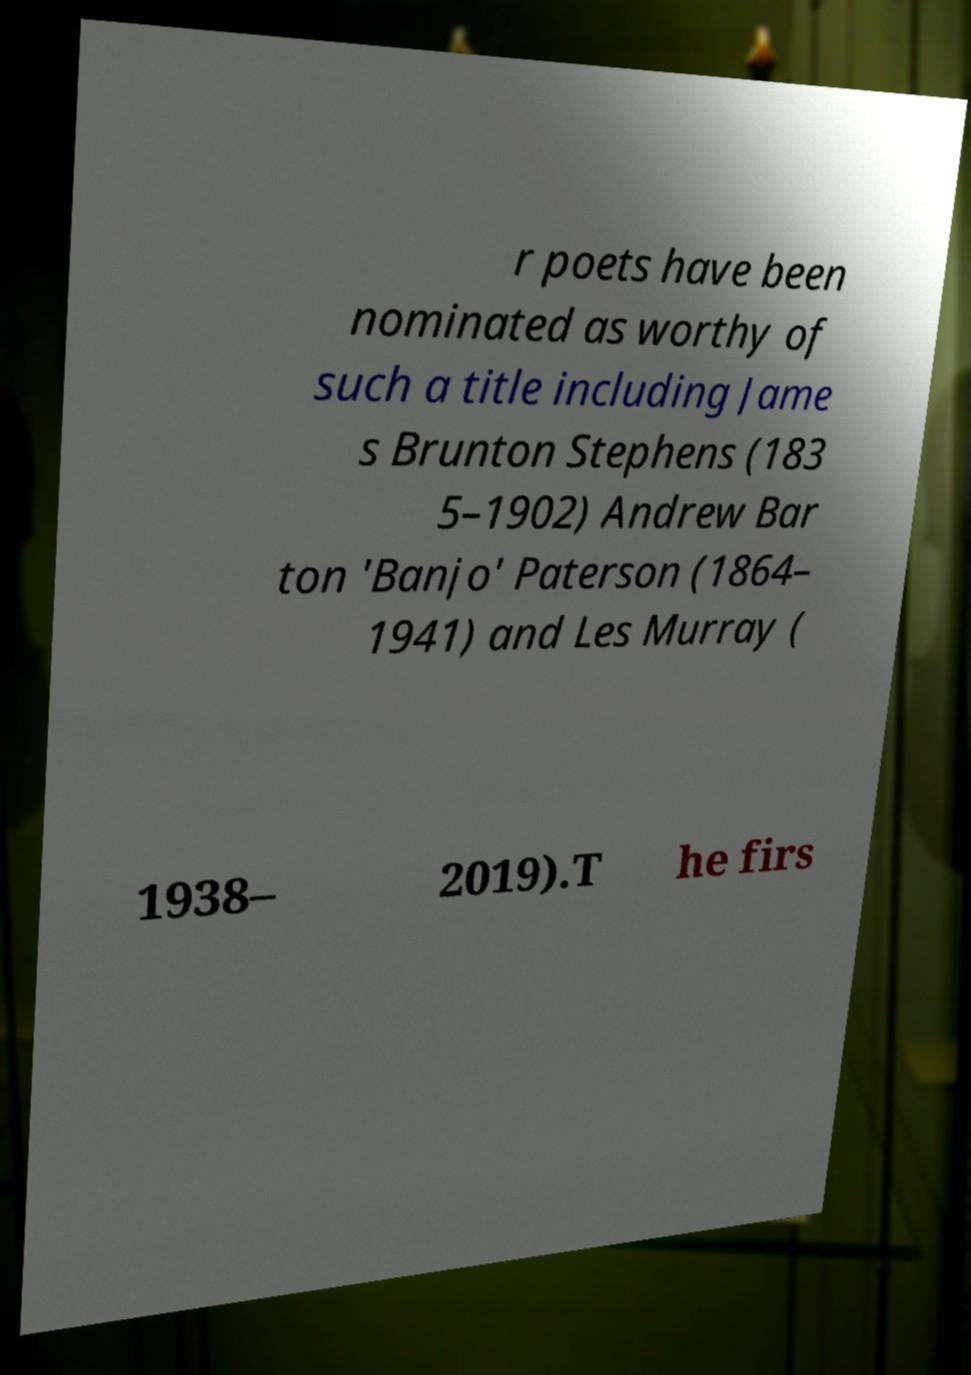Can you read and provide the text displayed in the image?This photo seems to have some interesting text. Can you extract and type it out for me? r poets have been nominated as worthy of such a title including Jame s Brunton Stephens (183 5–1902) Andrew Bar ton 'Banjo' Paterson (1864– 1941) and Les Murray ( 1938– 2019).T he firs 